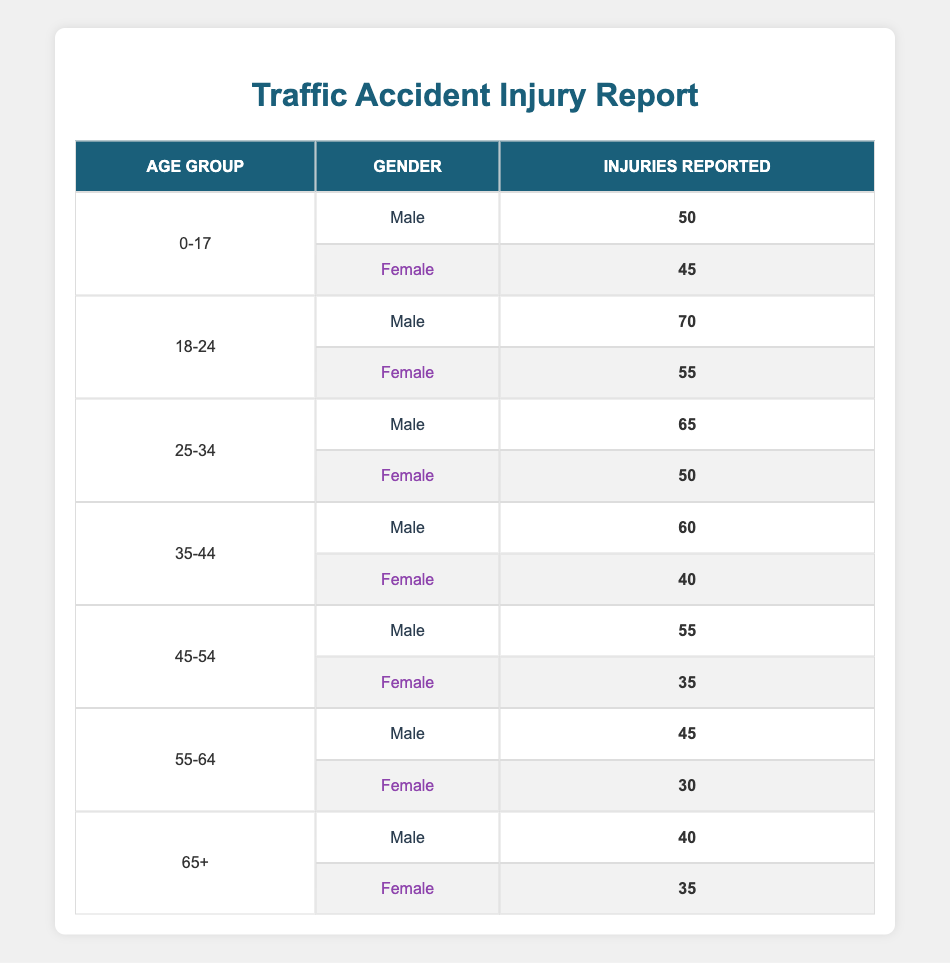What is the total number of injuries reported for males in the age group 18-24? There are two entries for the age group 18-24 for males: 70 injuries reported. Since there is only one entry, we take that value directly.
Answer: 70 What is the total number of injuries reported for females in the age group 45-54? For the age group 45-54, there is one entry for females reporting 35 injuries. Thus, the total is that single value.
Answer: 35 How many injuries were reported for both genders in the age group 25-34? There are entries for the age group 25-34: for males, there are 65 injuries, and for females, there are 50 injuries. Adding these gives us 65 + 50 = 115 total injuries.
Answer: 115 Are there more injuries reported for females or males in the age group 35-44? For males in the 35-44 age group, 60 injuries were reported, while for females, it is 40. Since 60 > 40, it indicates there are more injuries for males.
Answer: Yes What is the difference in injuries reported between males and females in the age group 55-64? For the age group 55-64, males reported 45 injuries, and females reported 30 injuries. The difference is calculated as 45 - 30 = 15.
Answer: 15 What is the total number of injuries reported across all age groups for males? To find this, we need to sum up the reported injuries for all male entries: 50 + 70 + 65 + 60 + 55 + 45 + 40 = 385.
Answer: 385 Is the number of injuries reported for age group 0-17 higher for males than females? For the age group 0-17, males reported 50 injuries while females reported 45. Since 50 > 45, more injuries were reported for males.
Answer: Yes What is the average number of injuries reported for females in the age group 65+? There is only one entry for females in the age group 65+, reporting 35 injuries. So, the average is simply the total, which is 35/1 = 35.
Answer: 35 Which age group reported the highest number of injuries for females? The highest number of injuries reported for females can be identified from their entries: 45 for 0-17, 55 for 18-24, 50 for 25-34, 40 for 35-44, 35 for 45-54, 30 for 55-64, and 35 for 65+. The maximum is 55 from the age group 18-24.
Answer: 18-24 